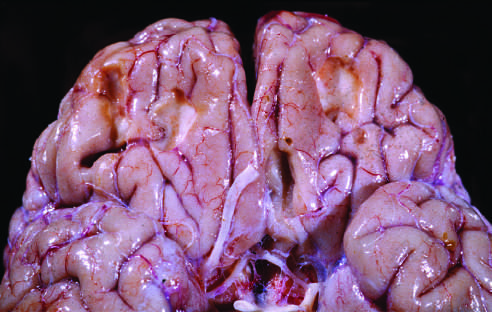re the lumen of the bronchus present on the inferior frontal surface of this brain?
Answer the question using a single word or phrase. No 